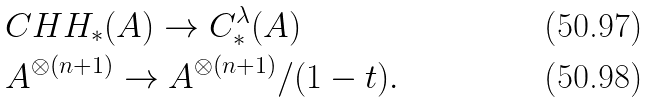<formula> <loc_0><loc_0><loc_500><loc_500>& C H H _ { * } ( A ) \to C _ { * } ^ { \lambda } ( A ) \\ & A ^ { \otimes ( n + 1 ) } \to A ^ { \otimes ( n + 1 ) } / ( 1 - t ) .</formula> 